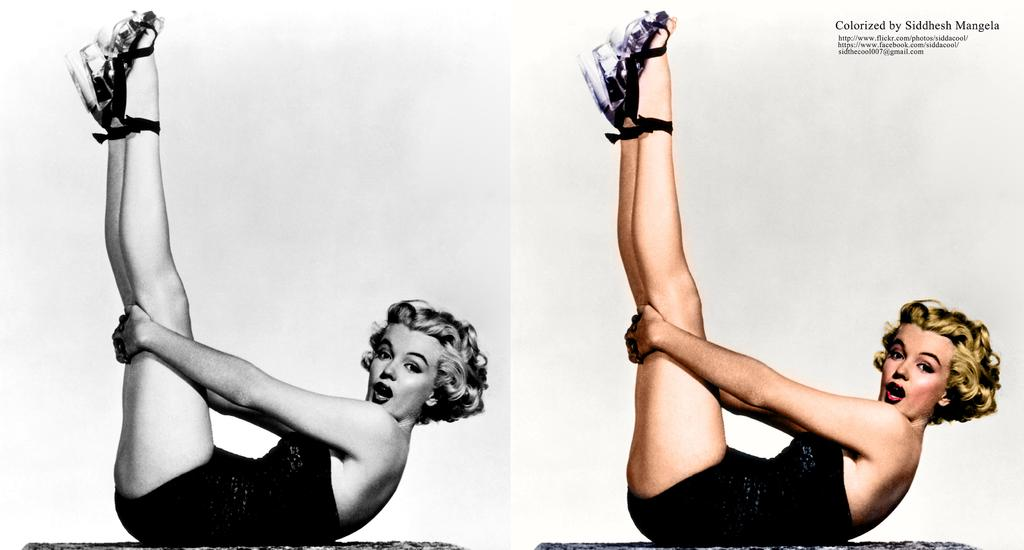What is the main subject of the image? The main subject of the image is a woman, as it is a collage of her. How is the first image of the woman presented? The first image of the woman is in black and white. What can be found in the second image of the woman? There is some text in the second image at the top right side. What does the sign say about the woman's throat in the image? There is no sign present in the image, and therefore no information about the woman's throat can be obtained from it. 